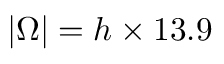<formula> <loc_0><loc_0><loc_500><loc_500>| \Omega | = h \times 1 3 . 9</formula> 